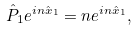Convert formula to latex. <formula><loc_0><loc_0><loc_500><loc_500>\hat { P } _ { 1 } e ^ { i n \hat { x } _ { 1 } } = n e ^ { i n \hat { x } _ { 1 } } ,</formula> 